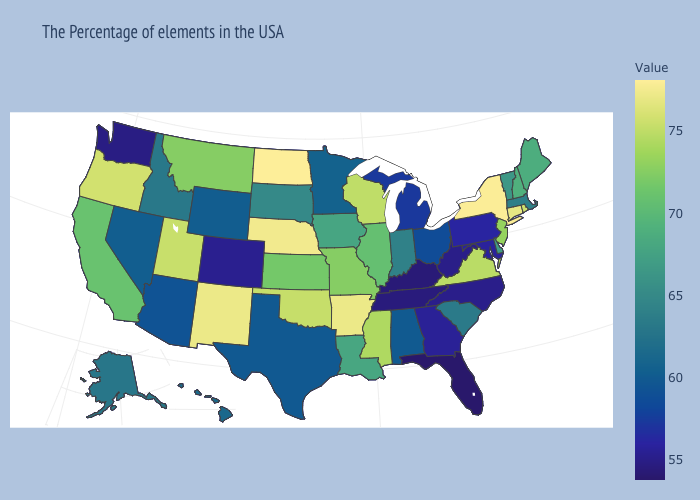Among the states that border North Dakota , does South Dakota have the lowest value?
Be succinct. No. Does the map have missing data?
Keep it brief. No. Does New Mexico have the highest value in the West?
Be succinct. Yes. Does Washington have a higher value than Alaska?
Write a very short answer. No. Does North Dakota have the highest value in the USA?
Quick response, please. Yes. 